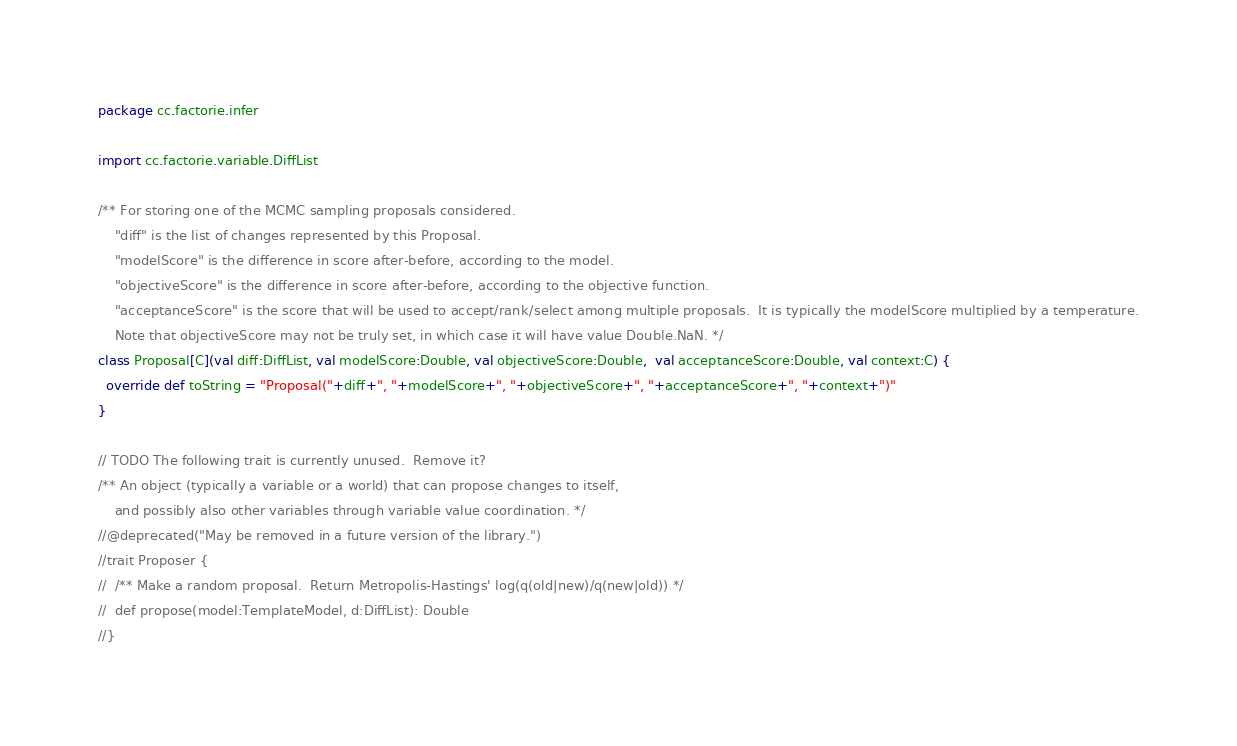Convert code to text. <code><loc_0><loc_0><loc_500><loc_500><_Scala_>package cc.factorie.infer

import cc.factorie.variable.DiffList

/** For storing one of the MCMC sampling proposals considered.
    "diff" is the list of changes represented by this Proposal.
    "modelScore" is the difference in score after-before, according to the model.
    "objectiveScore" is the difference in score after-before, according to the objective function.
    "acceptanceScore" is the score that will be used to accept/rank/select among multiple proposals.  It is typically the modelScore multiplied by a temperature.
    Note that objectiveScore may not be truly set, in which case it will have value Double.NaN. */
class Proposal[C](val diff:DiffList, val modelScore:Double, val objectiveScore:Double,  val acceptanceScore:Double, val context:C) {
  override def toString = "Proposal("+diff+", "+modelScore+", "+objectiveScore+", "+acceptanceScore+", "+context+")"
}

// TODO The following trait is currently unused.  Remove it?
/** An object (typically a variable or a world) that can propose changes to itself, 
    and possibly also other variables through variable value coordination. */
//@deprecated("May be removed in a future version of the library.")
//trait Proposer {
//  /** Make a random proposal.  Return Metropolis-Hastings' log(q(old|new)/q(new|old)) */
//  def propose(model:TemplateModel, d:DiffList): Double
//}
</code> 